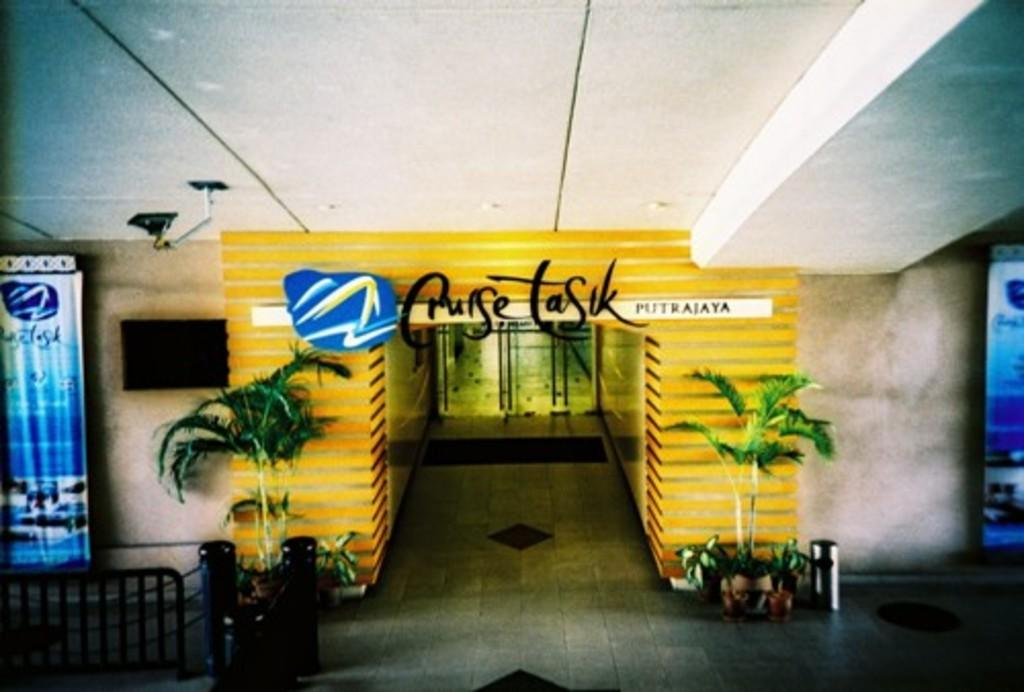What is on the arch in the image? There is a signboard on an arch in the image. What else can be seen in the image besides the signboard? There are banners, a fence, poles, a dustbin, plants in pots, a display screen on a wall, and a light on a roof in the image. Can you describe the fence in the image? There is a fence in the image, but its specific details are not mentioned in the provided facts. What type of plants are in the pots in the image? The provided facts do not specify the type of plants in the pots. How many snakes are wrapped around the light on the roof in the image? There are no snakes present in the image; only a light on a roof is mentioned. What type of shock can be seen coming from the display screen in the image? There is no shock present in the image; only a display screen on a wall is mentioned. 